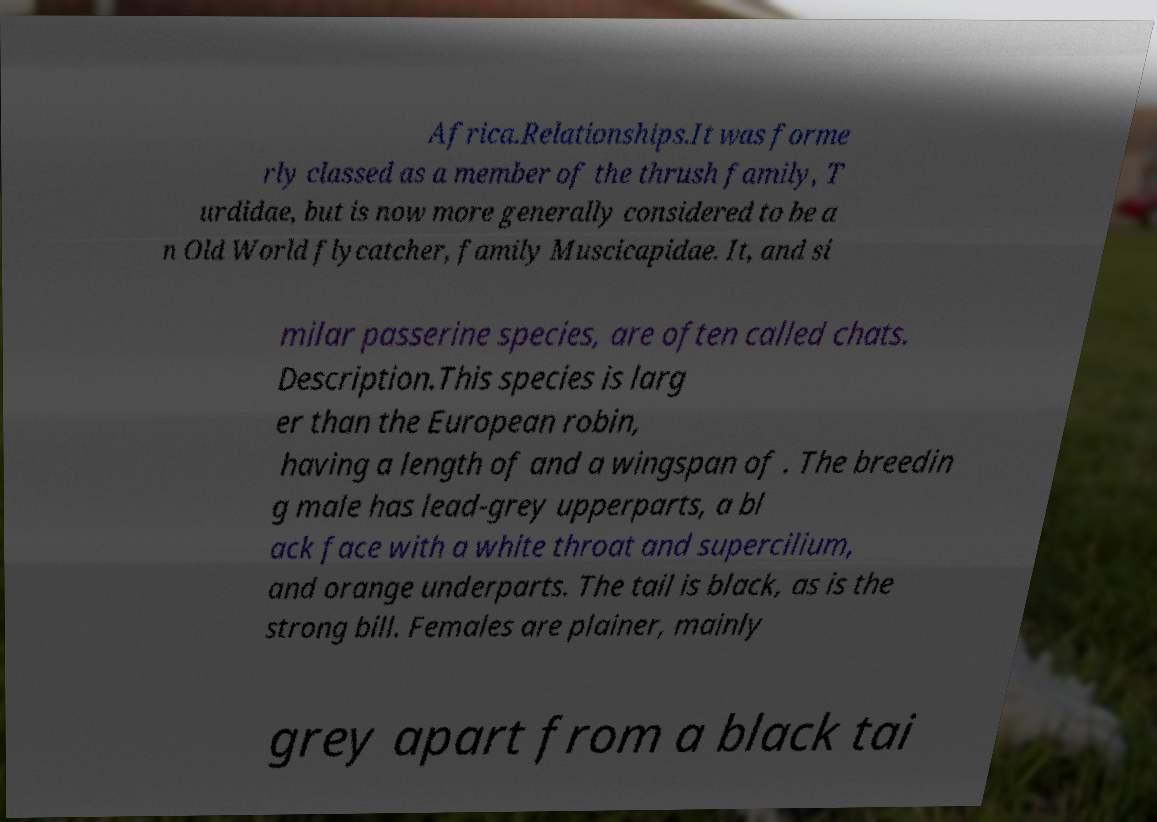For documentation purposes, I need the text within this image transcribed. Could you provide that? Africa.Relationships.It was forme rly classed as a member of the thrush family, T urdidae, but is now more generally considered to be a n Old World flycatcher, family Muscicapidae. It, and si milar passerine species, are often called chats. Description.This species is larg er than the European robin, having a length of and a wingspan of . The breedin g male has lead-grey upperparts, a bl ack face with a white throat and supercilium, and orange underparts. The tail is black, as is the strong bill. Females are plainer, mainly grey apart from a black tai 